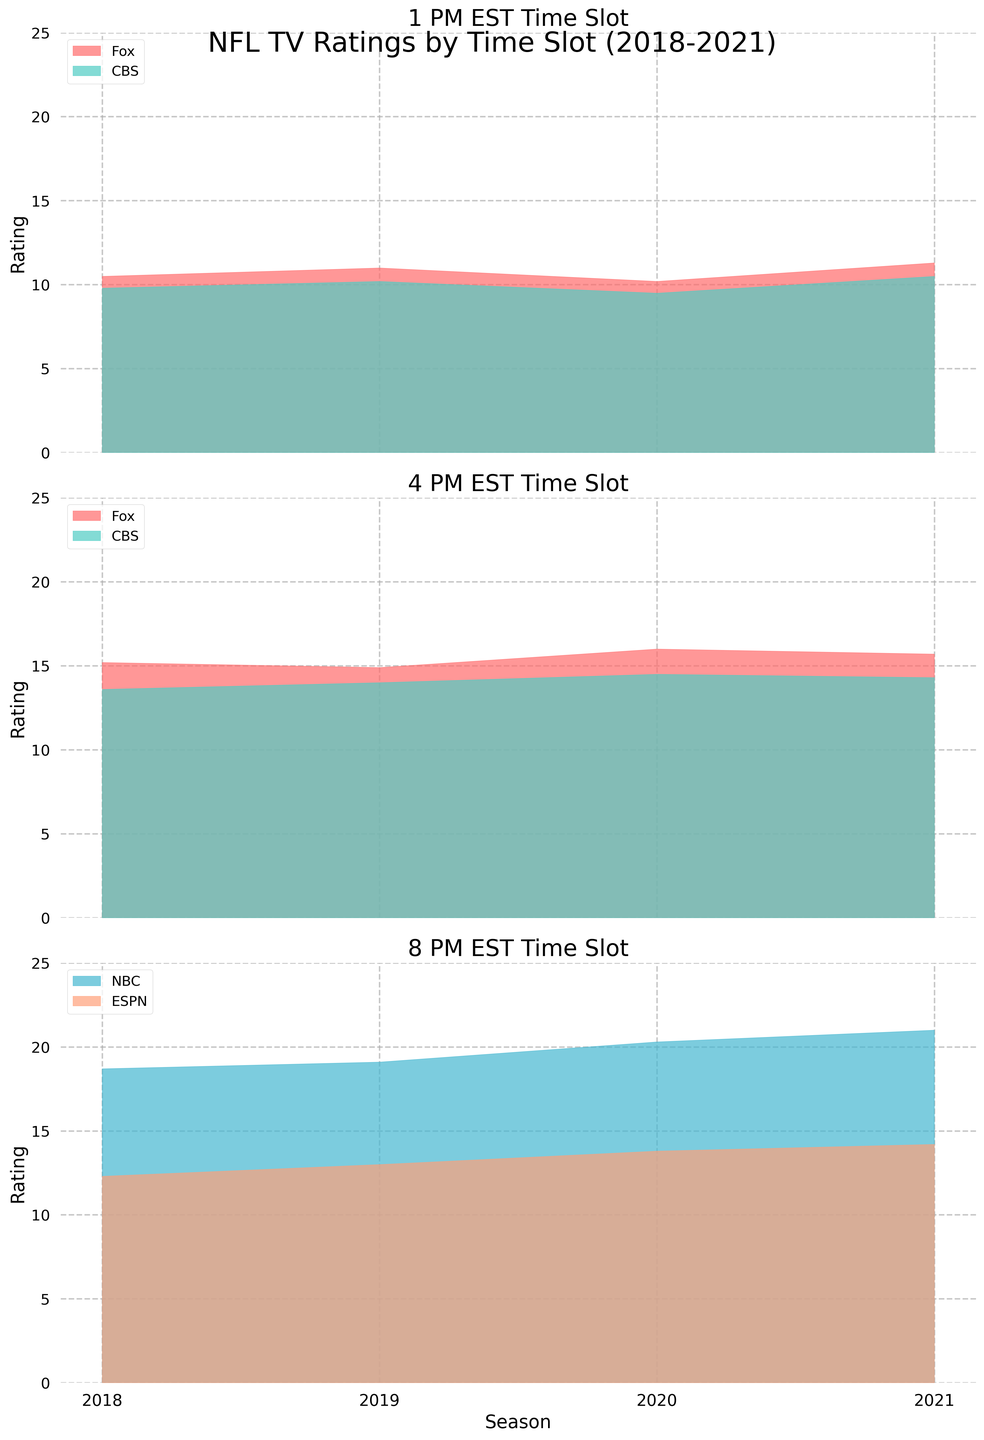What is the overall title of the figure? The title is found at the top of the figure, which provides a summary of what the entire figure is about. It is helpful for understanding the general content of the figure.
Answer: NFL TV Ratings by Time Slot (2018-2021) Which network had the highest rating in the 8 PM EST time slot in 2021? Look at the 8 PM EST subplot and identify which network's area reaches the highest value on the rating axis in 2021. The shaded area for NBC reaches the highest point.
Answer: NBC What is the difference in ratings between Fox and CBS during the 4 PM EST time slot in 2019? Check the 4 PM EST subplot and look at the ratings for Fox and CBS in 2019. Fox has a rating of 14.9, and CBS has a rating of 14.0. Subtract the two values to get the difference.
Answer: 0.9 Which network experienced the largest increase in ratings from 2018 to 2021 in the 8 PM EST time slot? Examine the 8 PM EST subplot and see how the rating for each network changes from 2018 to 2021. NBC's ratings increased the most from 18.7 in 2018 to 21.0 in 2021.
Answer: NBC How did Fox’s ratings change in the 1 PM EST time slot from 2018 to 2020? Look at the 1 PM EST subplot and follow the trend line for Fox from 2018 to 2020. The ratings are 10.5 in 2018, 11.0 in 2019, and then decreased to 10.2 in 2020.
Answer: Increased then decreased Which year had the highest overall rating for the 4 PM EST time slot across all networks? Sum the ratings of Fox and CBS for each year in the 4 PM EST subplot. In 2020, Fox has 16.0 and CBS 14.5, which is the highest combined value.
Answer: 2020 In which year did ESPN receive its highest rating for the 8 PM EST time slot? Check the 8 PM EST subplot and look at the highest point of the shaded area for ESPN across all years. The highest rating for ESPN is in 2021 with 14.2.
Answer: 2021 What is the average rating for CBS in the 1 PM EST time slot across all seasons? Look at the ratings for CBS during the 1 PM EST time slot for all seasons and calculate the average: (9.8 + 10.2 + 9.5 + 10.5) / 4 = 10.0.
Answer: 10.0 Is there a trend in ratings for NBC during the 8 PM EST time slot from 2018 to 2021? Observe the 8 PM EST subplot and trace the changes in the ratings for NBC from 2018 to 2021. The ratings consistently increase from 18.7 to 21.0, indicating an upward trend.
Answer: Upward trend Which time slot shows the most variability in ratings across the years? Compare the range of ratings across different years for each time slot by examining all three subplots. The 8 PM EST slot shows the highest variability with ratings ranging from 12.3 to 21.0.
Answer: 8 PM EST 